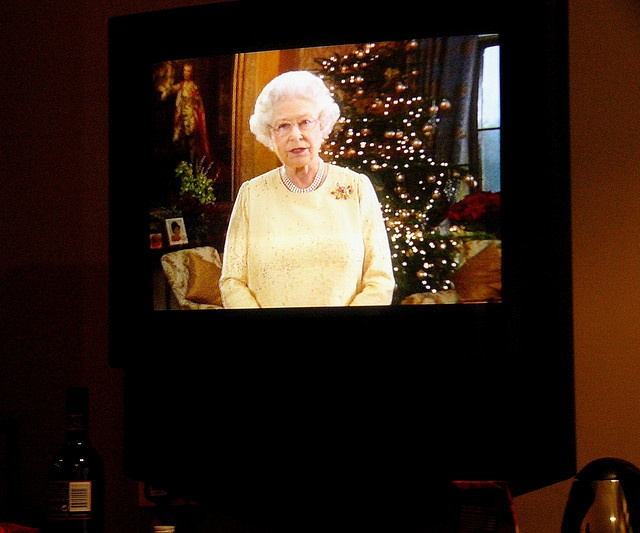Describe the objects in this image and their specific colors. I can see tv in black, beige, khaki, and maroon tones, people in black, beige, khaki, and tan tones, bottle in black, maroon, and olive tones, and chair in black, olive, maroon, and tan tones in this image. 